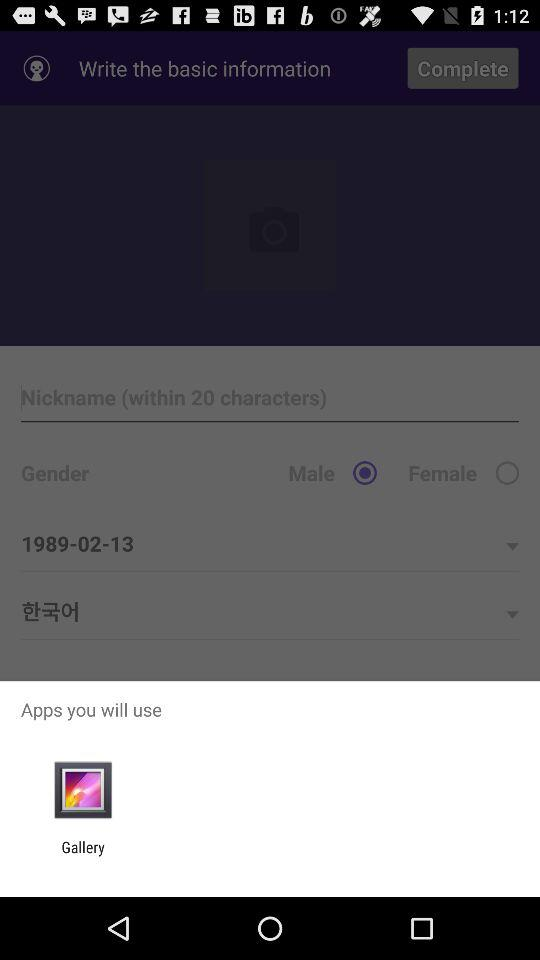How many options are there for the gender field?
Answer the question using a single word or phrase. 2 